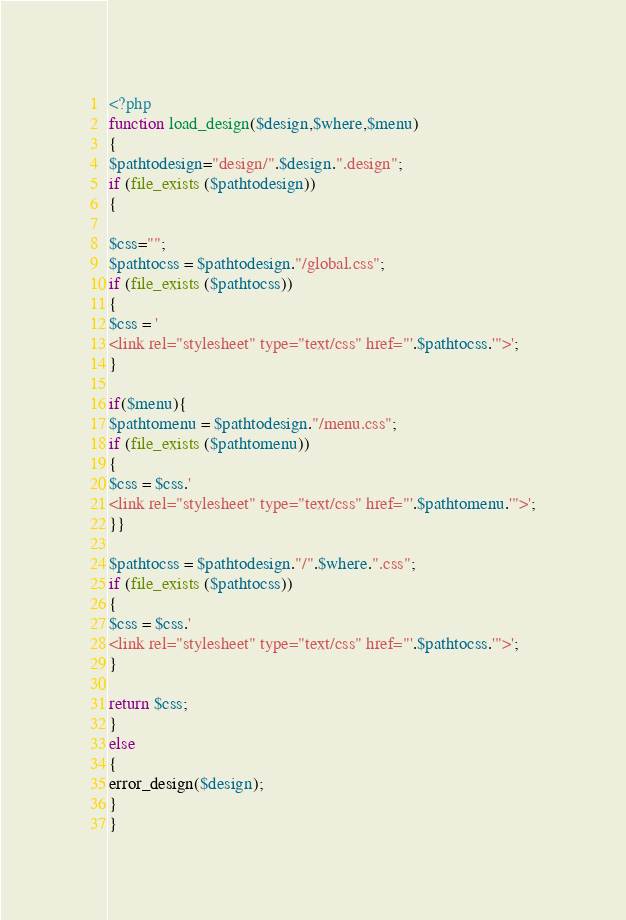<code> <loc_0><loc_0><loc_500><loc_500><_PHP_><?php
function load_design($design,$where,$menu)
{
$pathtodesign="design/".$design.".design";
if (file_exists ($pathtodesign))
{

$css="";
$pathtocss = $pathtodesign."/global.css";
if (file_exists ($pathtocss))
{
$css = '
<link rel="stylesheet" type="text/css" href="'.$pathtocss.'">';
}

if($menu){
$pathtomenu = $pathtodesign."/menu.css";
if (file_exists ($pathtomenu))
{
$css = $css.'
<link rel="stylesheet" type="text/css" href="'.$pathtomenu.'">';
}}

$pathtocss = $pathtodesign."/".$where.".css";
if (file_exists ($pathtocss))
{
$css = $css.'
<link rel="stylesheet" type="text/css" href="'.$pathtocss.'">';
}

return $css;
}
else
{
error_design($design);
}
}
</code> 